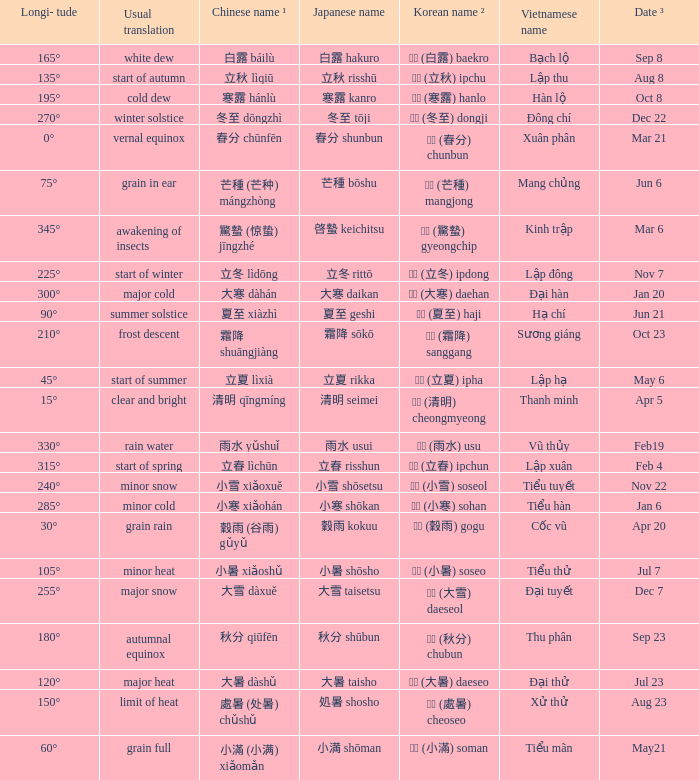Which Longi- tude is on jun 6? 75°. 